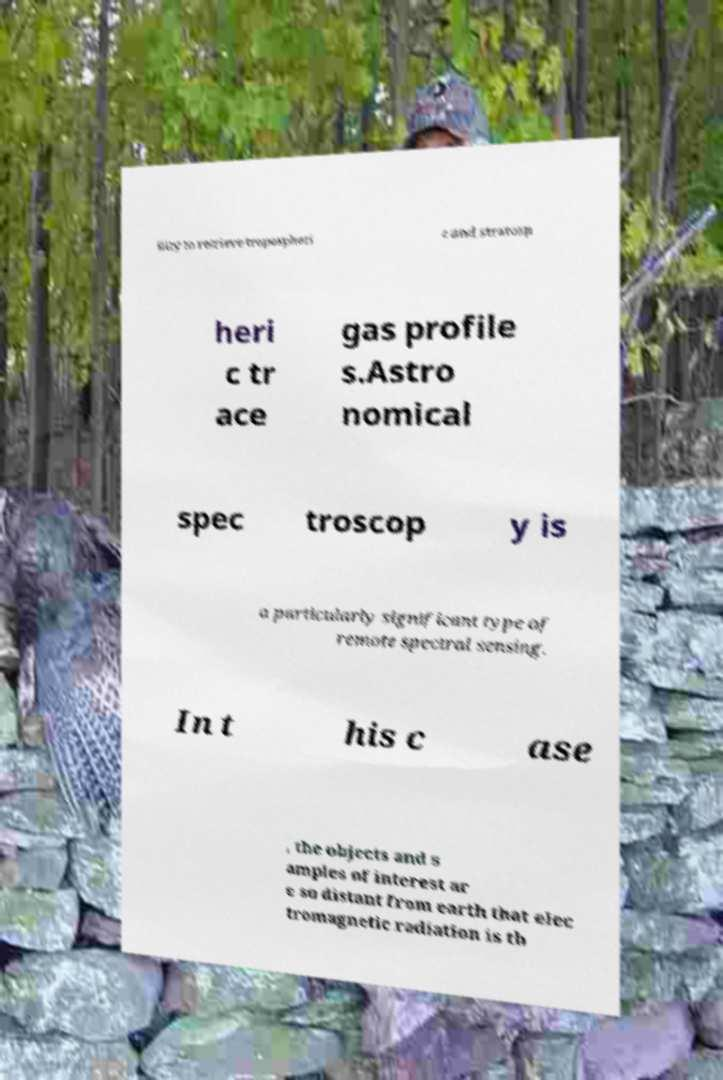Could you extract and type out the text from this image? ility to retrieve tropospheri c and stratosp heri c tr ace gas profile s.Astro nomical spec troscop y is a particularly significant type of remote spectral sensing. In t his c ase , the objects and s amples of interest ar e so distant from earth that elec tromagnetic radiation is th 